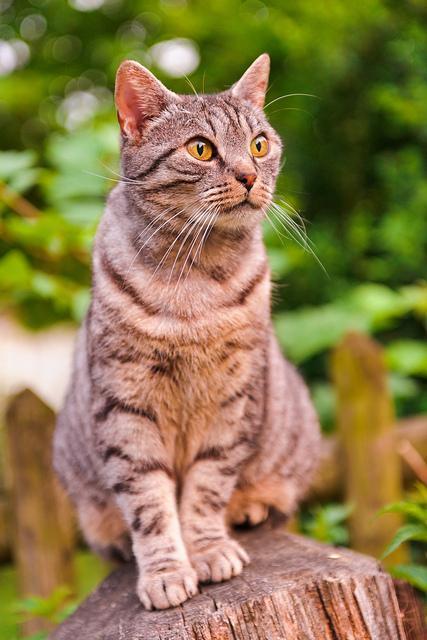How many people are wearing purple headbands?
Give a very brief answer. 0. 